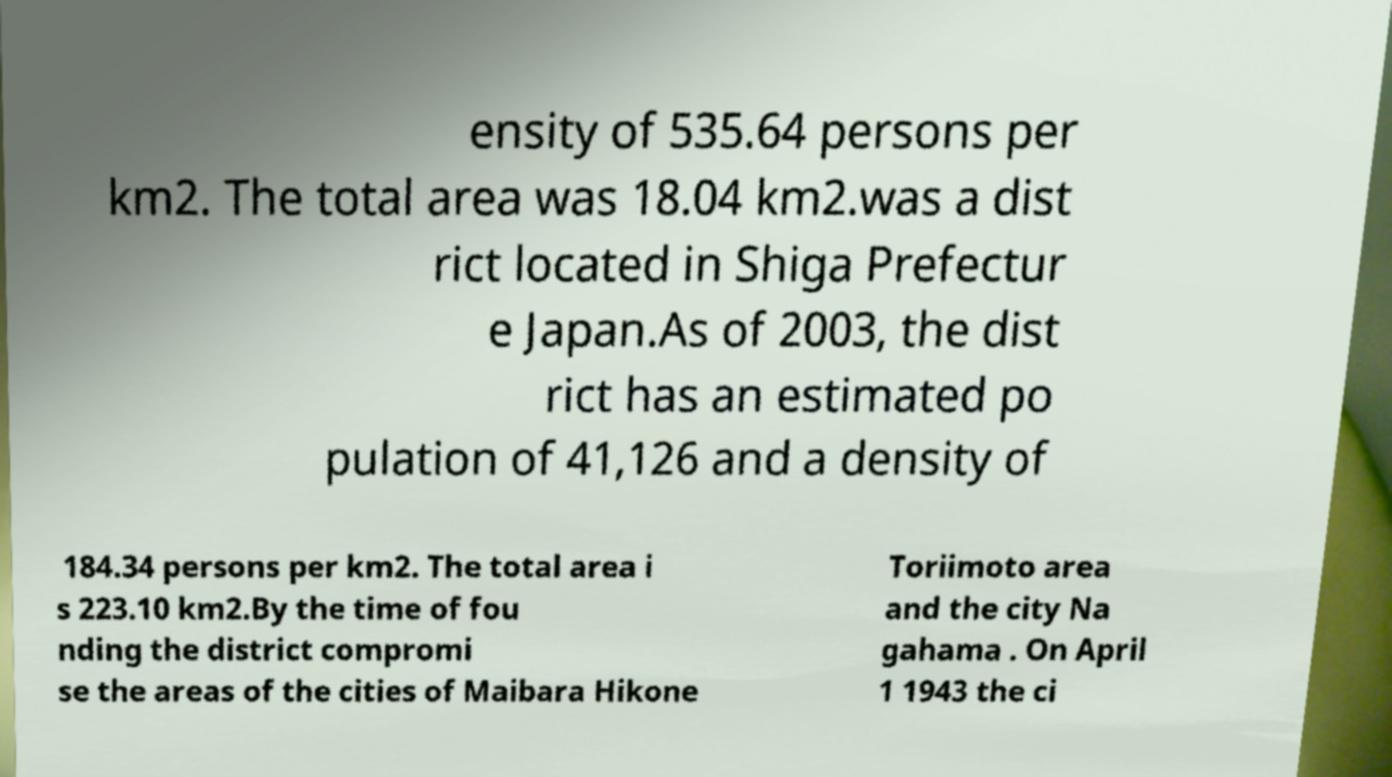What messages or text are displayed in this image? I need them in a readable, typed format. ensity of 535.64 persons per km2. The total area was 18.04 km2.was a dist rict located in Shiga Prefectur e Japan.As of 2003, the dist rict has an estimated po pulation of 41,126 and a density of 184.34 persons per km2. The total area i s 223.10 km2.By the time of fou nding the district compromi se the areas of the cities of Maibara Hikone Toriimoto area and the city Na gahama . On April 1 1943 the ci 